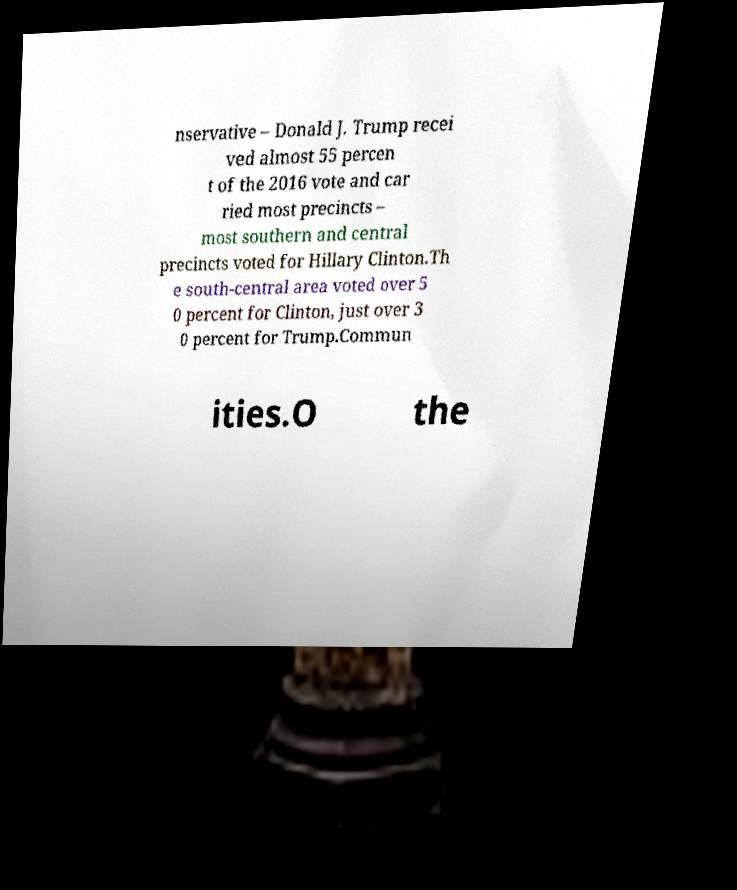Can you accurately transcribe the text from the provided image for me? nservative – Donald J. Trump recei ved almost 55 percen t of the 2016 vote and car ried most precincts – most southern and central precincts voted for Hillary Clinton.Th e south-central area voted over 5 0 percent for Clinton, just over 3 0 percent for Trump.Commun ities.O the 